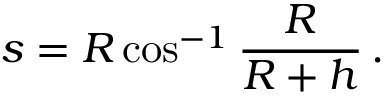<formula> <loc_0><loc_0><loc_500><loc_500>s = R \cos ^ { - 1 } { \frac { R } { R + h } } \, .</formula> 